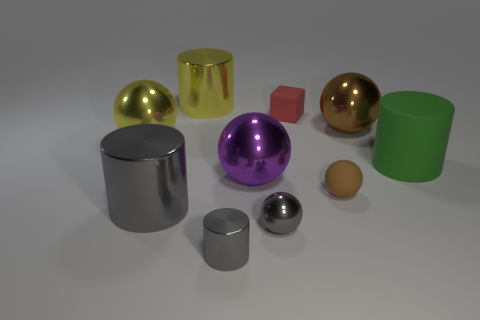Subtract 1 balls. How many balls are left? 4 Subtract all large yellow metallic spheres. How many spheres are left? 4 Subtract all gray spheres. How many spheres are left? 4 Subtract all green spheres. Subtract all blue blocks. How many spheres are left? 5 Subtract all blocks. How many objects are left? 9 Add 4 tiny cubes. How many tiny cubes exist? 5 Subtract 1 yellow spheres. How many objects are left? 9 Subtract all green cylinders. Subtract all red matte things. How many objects are left? 8 Add 9 big yellow balls. How many big yellow balls are left? 10 